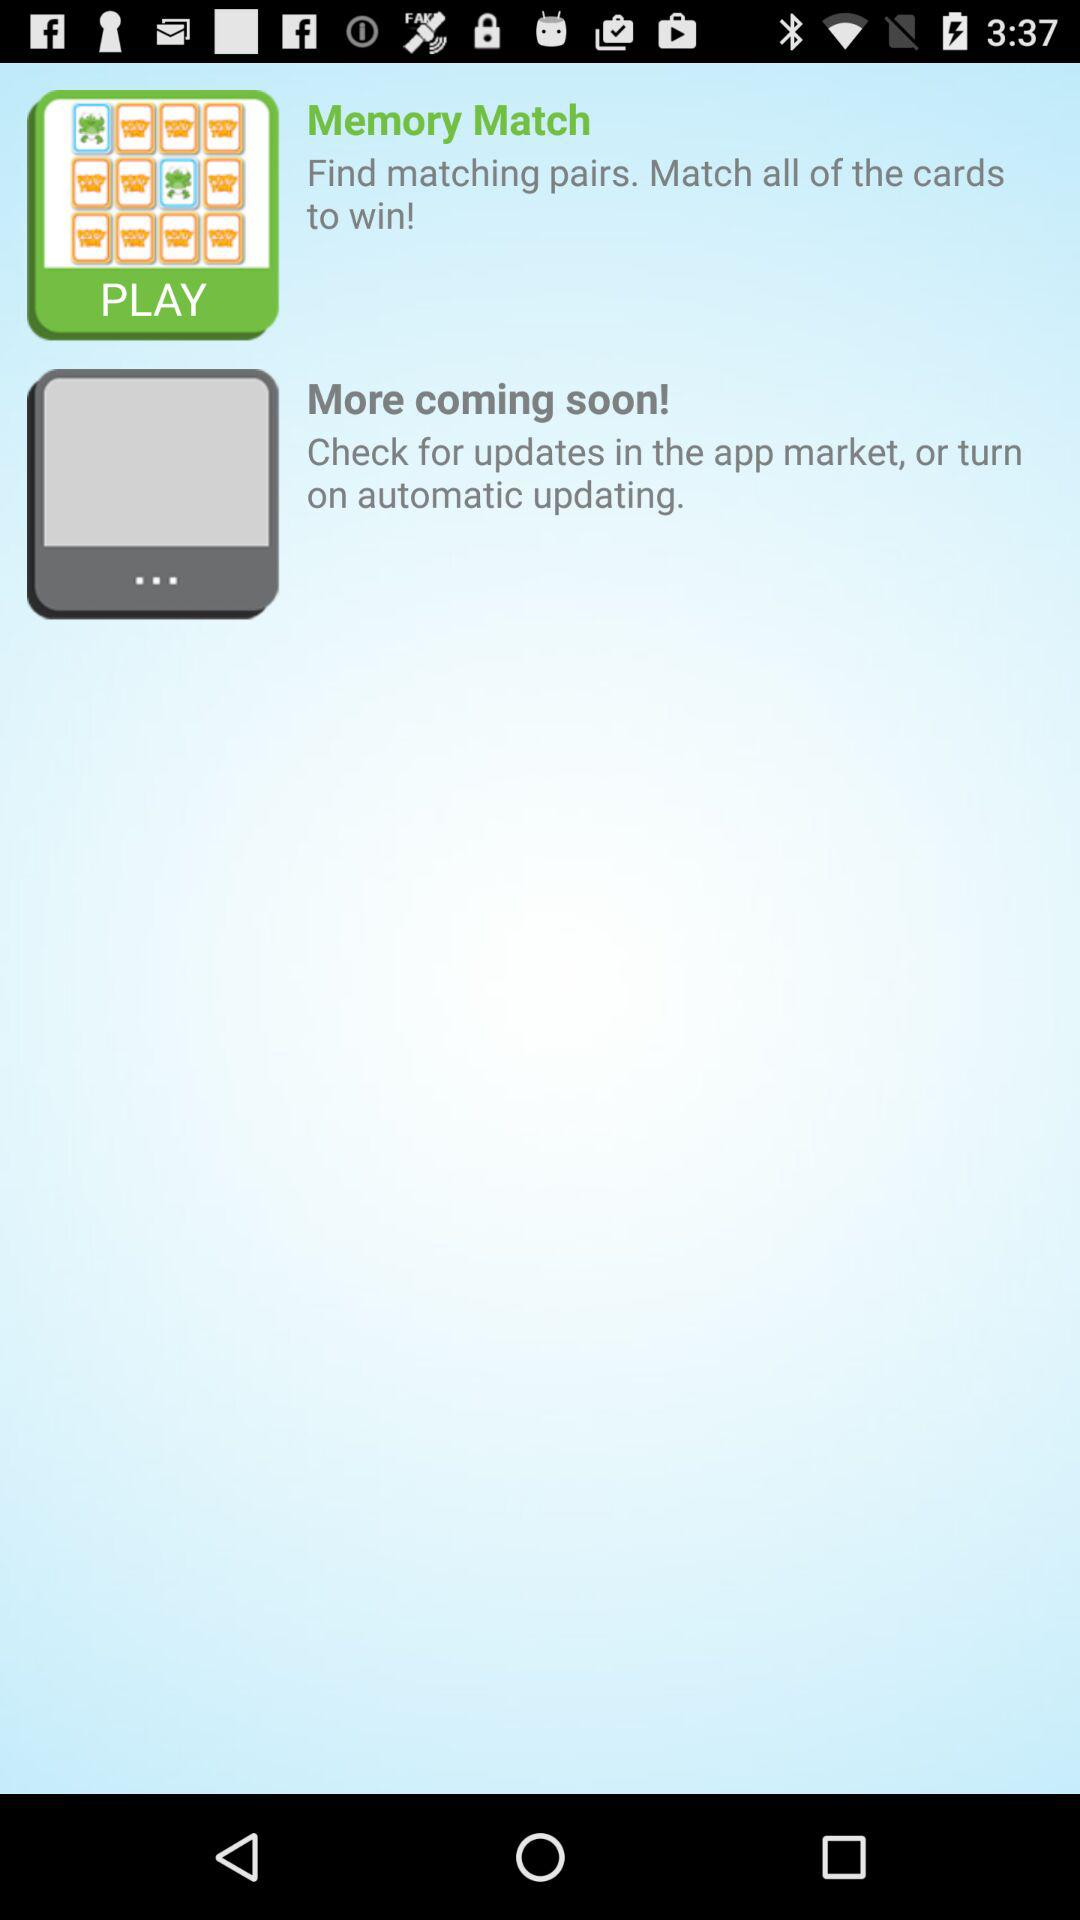What instructions are given to play the game? The instructions are "Find matching pairs. Match all of the cards to win!". 